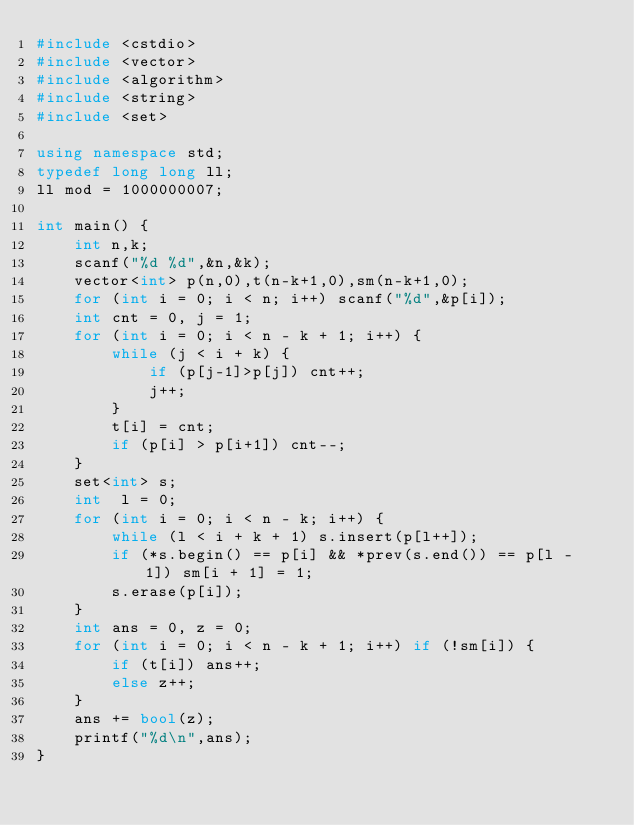Convert code to text. <code><loc_0><loc_0><loc_500><loc_500><_C++_>#include <cstdio>
#include <vector>
#include <algorithm>
#include <string>
#include <set>

using namespace std;
typedef long long ll;
ll mod = 1000000007;

int main() {
    int n,k;
    scanf("%d %d",&n,&k);
    vector<int> p(n,0),t(n-k+1,0),sm(n-k+1,0);
    for (int i = 0; i < n; i++) scanf("%d",&p[i]);
    int cnt = 0, j = 1;
    for (int i = 0; i < n - k + 1; i++) {
        while (j < i + k) {
            if (p[j-1]>p[j]) cnt++;
            j++;
        }
        t[i] = cnt;
        if (p[i] > p[i+1]) cnt--;
    }
    set<int> s;
    int  l = 0;
    for (int i = 0; i < n - k; i++) {
        while (l < i + k + 1) s.insert(p[l++]);
        if (*s.begin() == p[i] && *prev(s.end()) == p[l - 1]) sm[i + 1] = 1;
        s.erase(p[i]);
    }
    int ans = 0, z = 0;
    for (int i = 0; i < n - k + 1; i++) if (!sm[i]) {
        if (t[i]) ans++;
        else z++;
    }
    ans += bool(z);
    printf("%d\n",ans);
}</code> 